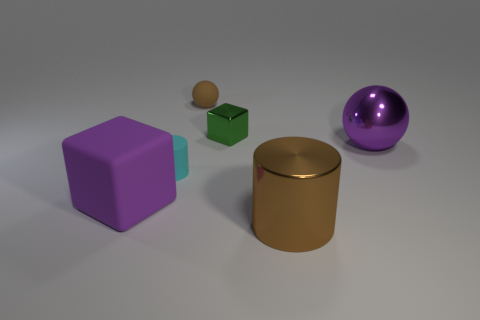What material is the small brown thing?
Provide a short and direct response. Rubber. There is a tiny thing that is the same color as the metal cylinder; what is its shape?
Your answer should be compact. Sphere. There is a cube in front of the sphere right of the shiny object in front of the purple rubber thing; what is its color?
Your answer should be very brief. Purple. Are there any big objects of the same shape as the small shiny object?
Provide a short and direct response. Yes. What number of tiny blue shiny things are there?
Ensure brevity in your answer.  0. What is the shape of the large rubber thing?
Ensure brevity in your answer.  Cube. How many other purple balls are the same size as the metal ball?
Your answer should be very brief. 0. Do the brown metal object and the cyan matte thing have the same shape?
Provide a succinct answer. Yes. The tiny thing that is on the left side of the brown object behind the metal cylinder is what color?
Offer a terse response. Cyan. There is a thing that is on the right side of the cyan rubber cylinder and to the left of the tiny green thing; what is its size?
Provide a succinct answer. Small. 